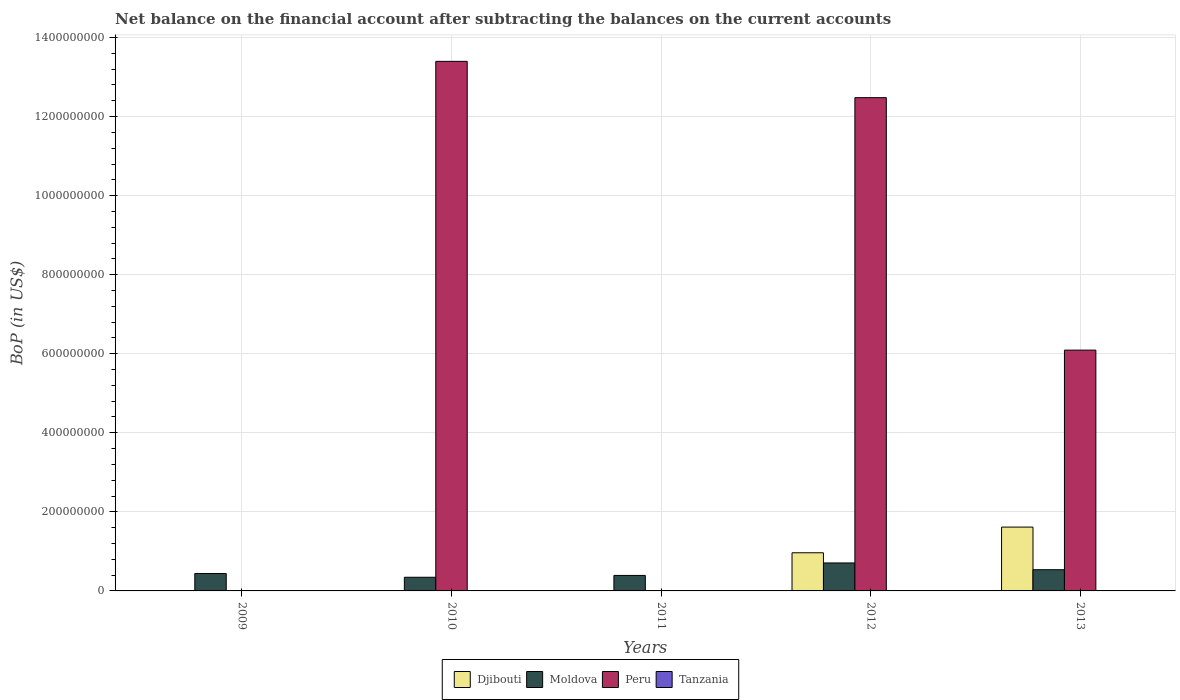Are the number of bars per tick equal to the number of legend labels?
Provide a succinct answer. No. How many bars are there on the 4th tick from the left?
Offer a terse response. 3. What is the label of the 3rd group of bars from the left?
Ensure brevity in your answer.  2011. What is the Balance of Payments in Peru in 2010?
Keep it short and to the point. 1.34e+09. Across all years, what is the maximum Balance of Payments in Peru?
Keep it short and to the point. 1.34e+09. In which year was the Balance of Payments in Peru maximum?
Your answer should be compact. 2010. What is the total Balance of Payments in Peru in the graph?
Provide a short and direct response. 3.20e+09. What is the difference between the Balance of Payments in Moldova in 2009 and that in 2010?
Ensure brevity in your answer.  9.56e+06. In the year 2013, what is the difference between the Balance of Payments in Peru and Balance of Payments in Moldova?
Provide a short and direct response. 5.56e+08. What is the ratio of the Balance of Payments in Djibouti in 2012 to that in 2013?
Keep it short and to the point. 0.6. Is the Balance of Payments in Peru in 2012 less than that in 2013?
Ensure brevity in your answer.  No. What is the difference between the highest and the second highest Balance of Payments in Peru?
Your answer should be compact. 9.18e+07. What is the difference between the highest and the lowest Balance of Payments in Peru?
Offer a terse response. 1.34e+09. Is the sum of the Balance of Payments in Djibouti in 2012 and 2013 greater than the maximum Balance of Payments in Tanzania across all years?
Provide a short and direct response. Yes. Is it the case that in every year, the sum of the Balance of Payments in Moldova and Balance of Payments in Tanzania is greater than the Balance of Payments in Djibouti?
Ensure brevity in your answer.  No. How many bars are there?
Your answer should be compact. 10. What is the difference between two consecutive major ticks on the Y-axis?
Your answer should be very brief. 2.00e+08. Are the values on the major ticks of Y-axis written in scientific E-notation?
Ensure brevity in your answer.  No. How are the legend labels stacked?
Your answer should be very brief. Horizontal. What is the title of the graph?
Ensure brevity in your answer.  Net balance on the financial account after subtracting the balances on the current accounts. What is the label or title of the Y-axis?
Provide a short and direct response. BoP (in US$). What is the BoP (in US$) of Moldova in 2009?
Offer a very short reply. 4.41e+07. What is the BoP (in US$) of Peru in 2009?
Ensure brevity in your answer.  0. What is the BoP (in US$) of Djibouti in 2010?
Ensure brevity in your answer.  0. What is the BoP (in US$) in Moldova in 2010?
Your response must be concise. 3.46e+07. What is the BoP (in US$) of Peru in 2010?
Provide a short and direct response. 1.34e+09. What is the BoP (in US$) of Djibouti in 2011?
Ensure brevity in your answer.  0. What is the BoP (in US$) in Moldova in 2011?
Offer a terse response. 3.92e+07. What is the BoP (in US$) in Peru in 2011?
Your answer should be compact. 0. What is the BoP (in US$) of Djibouti in 2012?
Offer a terse response. 9.65e+07. What is the BoP (in US$) in Moldova in 2012?
Give a very brief answer. 7.08e+07. What is the BoP (in US$) of Peru in 2012?
Offer a terse response. 1.25e+09. What is the BoP (in US$) in Djibouti in 2013?
Your response must be concise. 1.61e+08. What is the BoP (in US$) of Moldova in 2013?
Provide a succinct answer. 5.37e+07. What is the BoP (in US$) in Peru in 2013?
Keep it short and to the point. 6.09e+08. What is the BoP (in US$) of Tanzania in 2013?
Your response must be concise. 0. Across all years, what is the maximum BoP (in US$) in Djibouti?
Keep it short and to the point. 1.61e+08. Across all years, what is the maximum BoP (in US$) in Moldova?
Keep it short and to the point. 7.08e+07. Across all years, what is the maximum BoP (in US$) in Peru?
Your response must be concise. 1.34e+09. Across all years, what is the minimum BoP (in US$) of Moldova?
Offer a terse response. 3.46e+07. Across all years, what is the minimum BoP (in US$) in Peru?
Make the answer very short. 0. What is the total BoP (in US$) in Djibouti in the graph?
Offer a terse response. 2.58e+08. What is the total BoP (in US$) in Moldova in the graph?
Your response must be concise. 2.42e+08. What is the total BoP (in US$) in Peru in the graph?
Offer a terse response. 3.20e+09. What is the difference between the BoP (in US$) of Moldova in 2009 and that in 2010?
Ensure brevity in your answer.  9.56e+06. What is the difference between the BoP (in US$) of Moldova in 2009 and that in 2011?
Ensure brevity in your answer.  4.93e+06. What is the difference between the BoP (in US$) in Moldova in 2009 and that in 2012?
Your answer should be compact. -2.67e+07. What is the difference between the BoP (in US$) in Moldova in 2009 and that in 2013?
Your answer should be compact. -9.55e+06. What is the difference between the BoP (in US$) of Moldova in 2010 and that in 2011?
Offer a terse response. -4.63e+06. What is the difference between the BoP (in US$) in Moldova in 2010 and that in 2012?
Your response must be concise. -3.62e+07. What is the difference between the BoP (in US$) of Peru in 2010 and that in 2012?
Keep it short and to the point. 9.18e+07. What is the difference between the BoP (in US$) of Moldova in 2010 and that in 2013?
Keep it short and to the point. -1.91e+07. What is the difference between the BoP (in US$) in Peru in 2010 and that in 2013?
Make the answer very short. 7.31e+08. What is the difference between the BoP (in US$) of Moldova in 2011 and that in 2012?
Offer a terse response. -3.16e+07. What is the difference between the BoP (in US$) of Moldova in 2011 and that in 2013?
Your answer should be compact. -1.45e+07. What is the difference between the BoP (in US$) in Djibouti in 2012 and that in 2013?
Offer a terse response. -6.50e+07. What is the difference between the BoP (in US$) of Moldova in 2012 and that in 2013?
Provide a short and direct response. 1.71e+07. What is the difference between the BoP (in US$) in Peru in 2012 and that in 2013?
Ensure brevity in your answer.  6.39e+08. What is the difference between the BoP (in US$) of Moldova in 2009 and the BoP (in US$) of Peru in 2010?
Ensure brevity in your answer.  -1.30e+09. What is the difference between the BoP (in US$) of Moldova in 2009 and the BoP (in US$) of Peru in 2012?
Provide a succinct answer. -1.20e+09. What is the difference between the BoP (in US$) in Moldova in 2009 and the BoP (in US$) in Peru in 2013?
Give a very brief answer. -5.65e+08. What is the difference between the BoP (in US$) in Moldova in 2010 and the BoP (in US$) in Peru in 2012?
Keep it short and to the point. -1.21e+09. What is the difference between the BoP (in US$) in Moldova in 2010 and the BoP (in US$) in Peru in 2013?
Offer a very short reply. -5.75e+08. What is the difference between the BoP (in US$) of Moldova in 2011 and the BoP (in US$) of Peru in 2012?
Offer a very short reply. -1.21e+09. What is the difference between the BoP (in US$) of Moldova in 2011 and the BoP (in US$) of Peru in 2013?
Give a very brief answer. -5.70e+08. What is the difference between the BoP (in US$) in Djibouti in 2012 and the BoP (in US$) in Moldova in 2013?
Your answer should be compact. 4.28e+07. What is the difference between the BoP (in US$) in Djibouti in 2012 and the BoP (in US$) in Peru in 2013?
Provide a succinct answer. -5.13e+08. What is the difference between the BoP (in US$) of Moldova in 2012 and the BoP (in US$) of Peru in 2013?
Give a very brief answer. -5.38e+08. What is the average BoP (in US$) of Djibouti per year?
Give a very brief answer. 5.16e+07. What is the average BoP (in US$) in Moldova per year?
Provide a succinct answer. 4.85e+07. What is the average BoP (in US$) in Peru per year?
Provide a succinct answer. 6.39e+08. In the year 2010, what is the difference between the BoP (in US$) in Moldova and BoP (in US$) in Peru?
Provide a short and direct response. -1.31e+09. In the year 2012, what is the difference between the BoP (in US$) in Djibouti and BoP (in US$) in Moldova?
Offer a very short reply. 2.57e+07. In the year 2012, what is the difference between the BoP (in US$) in Djibouti and BoP (in US$) in Peru?
Ensure brevity in your answer.  -1.15e+09. In the year 2012, what is the difference between the BoP (in US$) of Moldova and BoP (in US$) of Peru?
Make the answer very short. -1.18e+09. In the year 2013, what is the difference between the BoP (in US$) of Djibouti and BoP (in US$) of Moldova?
Provide a short and direct response. 1.08e+08. In the year 2013, what is the difference between the BoP (in US$) of Djibouti and BoP (in US$) of Peru?
Your response must be concise. -4.48e+08. In the year 2013, what is the difference between the BoP (in US$) of Moldova and BoP (in US$) of Peru?
Make the answer very short. -5.56e+08. What is the ratio of the BoP (in US$) in Moldova in 2009 to that in 2010?
Your answer should be very brief. 1.28. What is the ratio of the BoP (in US$) of Moldova in 2009 to that in 2011?
Give a very brief answer. 1.13. What is the ratio of the BoP (in US$) in Moldova in 2009 to that in 2012?
Provide a succinct answer. 0.62. What is the ratio of the BoP (in US$) in Moldova in 2009 to that in 2013?
Ensure brevity in your answer.  0.82. What is the ratio of the BoP (in US$) in Moldova in 2010 to that in 2011?
Your answer should be very brief. 0.88. What is the ratio of the BoP (in US$) in Moldova in 2010 to that in 2012?
Make the answer very short. 0.49. What is the ratio of the BoP (in US$) in Peru in 2010 to that in 2012?
Make the answer very short. 1.07. What is the ratio of the BoP (in US$) of Moldova in 2010 to that in 2013?
Your response must be concise. 0.64. What is the ratio of the BoP (in US$) of Peru in 2010 to that in 2013?
Provide a short and direct response. 2.2. What is the ratio of the BoP (in US$) of Moldova in 2011 to that in 2012?
Your response must be concise. 0.55. What is the ratio of the BoP (in US$) in Moldova in 2011 to that in 2013?
Keep it short and to the point. 0.73. What is the ratio of the BoP (in US$) in Djibouti in 2012 to that in 2013?
Your answer should be very brief. 0.6. What is the ratio of the BoP (in US$) of Moldova in 2012 to that in 2013?
Offer a very short reply. 1.32. What is the ratio of the BoP (in US$) in Peru in 2012 to that in 2013?
Provide a succinct answer. 2.05. What is the difference between the highest and the second highest BoP (in US$) of Moldova?
Your response must be concise. 1.71e+07. What is the difference between the highest and the second highest BoP (in US$) in Peru?
Ensure brevity in your answer.  9.18e+07. What is the difference between the highest and the lowest BoP (in US$) of Djibouti?
Provide a succinct answer. 1.61e+08. What is the difference between the highest and the lowest BoP (in US$) in Moldova?
Your answer should be very brief. 3.62e+07. What is the difference between the highest and the lowest BoP (in US$) of Peru?
Make the answer very short. 1.34e+09. 